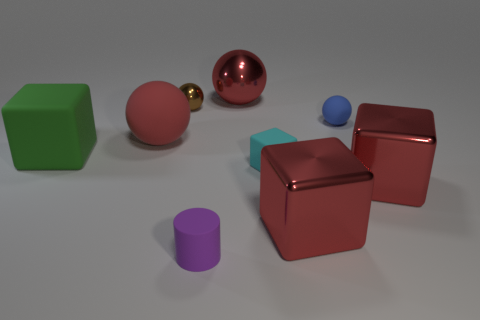Subtract all gray spheres. How many red cubes are left? 2 Subtract 1 blocks. How many blocks are left? 3 Subtract all cyan cubes. How many cubes are left? 3 Subtract all big blocks. How many blocks are left? 1 Add 1 tiny purple matte cylinders. How many objects exist? 10 Subtract all blocks. How many objects are left? 5 Subtract all purple cubes. Subtract all purple spheres. How many cubes are left? 4 Subtract all big cubes. Subtract all tiny cyan matte blocks. How many objects are left? 5 Add 3 purple cylinders. How many purple cylinders are left? 4 Add 7 matte cylinders. How many matte cylinders exist? 8 